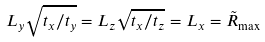<formula> <loc_0><loc_0><loc_500><loc_500>L _ { y } \sqrt { t _ { x } / t _ { y } } = L _ { z } \sqrt { t _ { x } / t _ { z } } = L _ { x } = \tilde { R } _ { \max }</formula> 